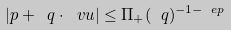Convert formula to latex. <formula><loc_0><loc_0><loc_500><loc_500>| p + \ q \cdot \ v u | \leq \Pi _ { + } ( \ q ) ^ { - 1 - \ e p }</formula> 